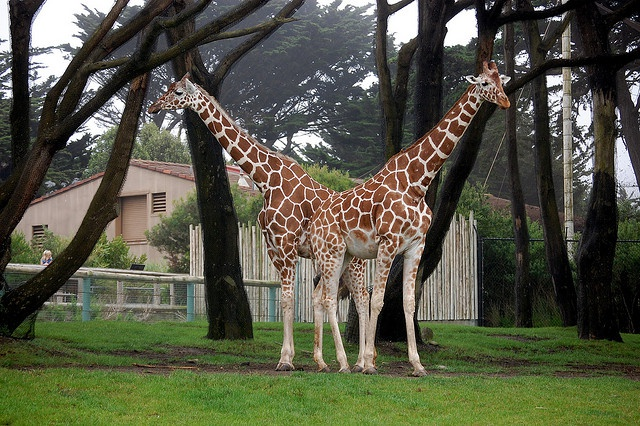Describe the objects in this image and their specific colors. I can see giraffe in white, darkgray, maroon, gray, and lightgray tones, giraffe in white, maroon, darkgray, gray, and lightgray tones, and people in white, darkgray, tan, and gray tones in this image. 